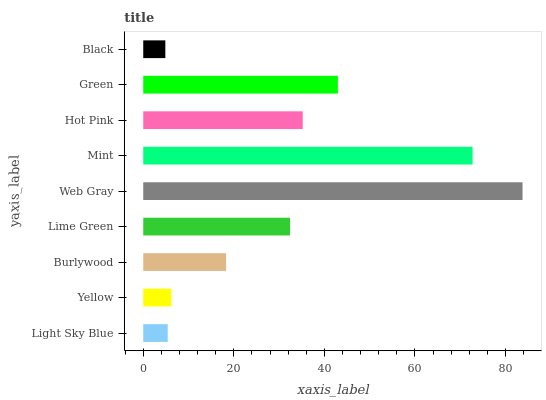Is Black the minimum?
Answer yes or no. Yes. Is Web Gray the maximum?
Answer yes or no. Yes. Is Yellow the minimum?
Answer yes or no. No. Is Yellow the maximum?
Answer yes or no. No. Is Yellow greater than Light Sky Blue?
Answer yes or no. Yes. Is Light Sky Blue less than Yellow?
Answer yes or no. Yes. Is Light Sky Blue greater than Yellow?
Answer yes or no. No. Is Yellow less than Light Sky Blue?
Answer yes or no. No. Is Lime Green the high median?
Answer yes or no. Yes. Is Lime Green the low median?
Answer yes or no. Yes. Is Hot Pink the high median?
Answer yes or no. No. Is Burlywood the low median?
Answer yes or no. No. 